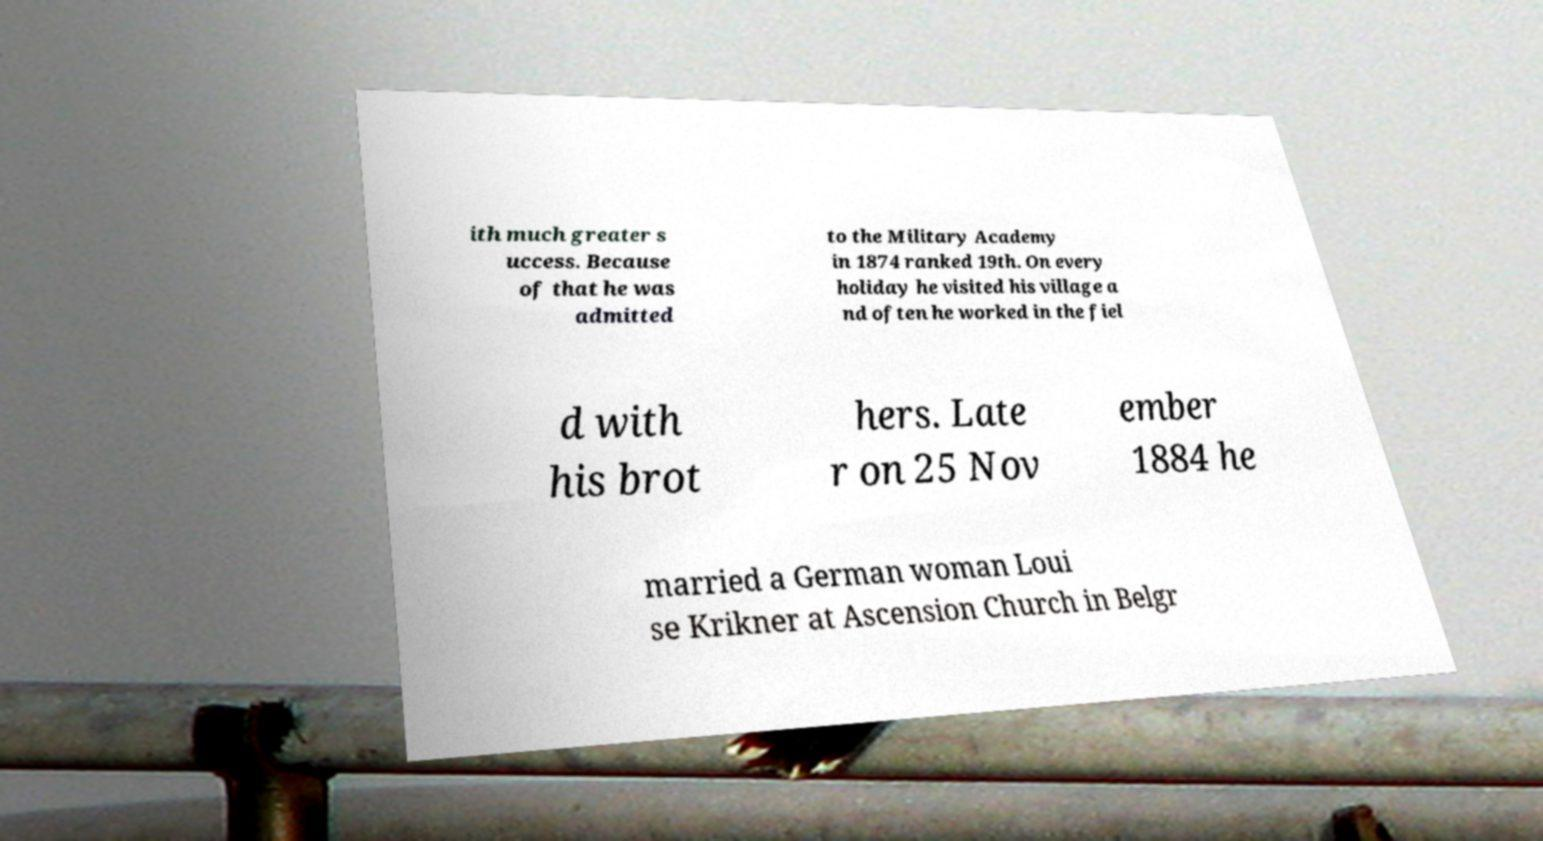Can you read and provide the text displayed in the image?This photo seems to have some interesting text. Can you extract and type it out for me? ith much greater s uccess. Because of that he was admitted to the Military Academy in 1874 ranked 19th. On every holiday he visited his village a nd often he worked in the fiel d with his brot hers. Late r on 25 Nov ember 1884 he married a German woman Loui se Krikner at Ascension Church in Belgr 